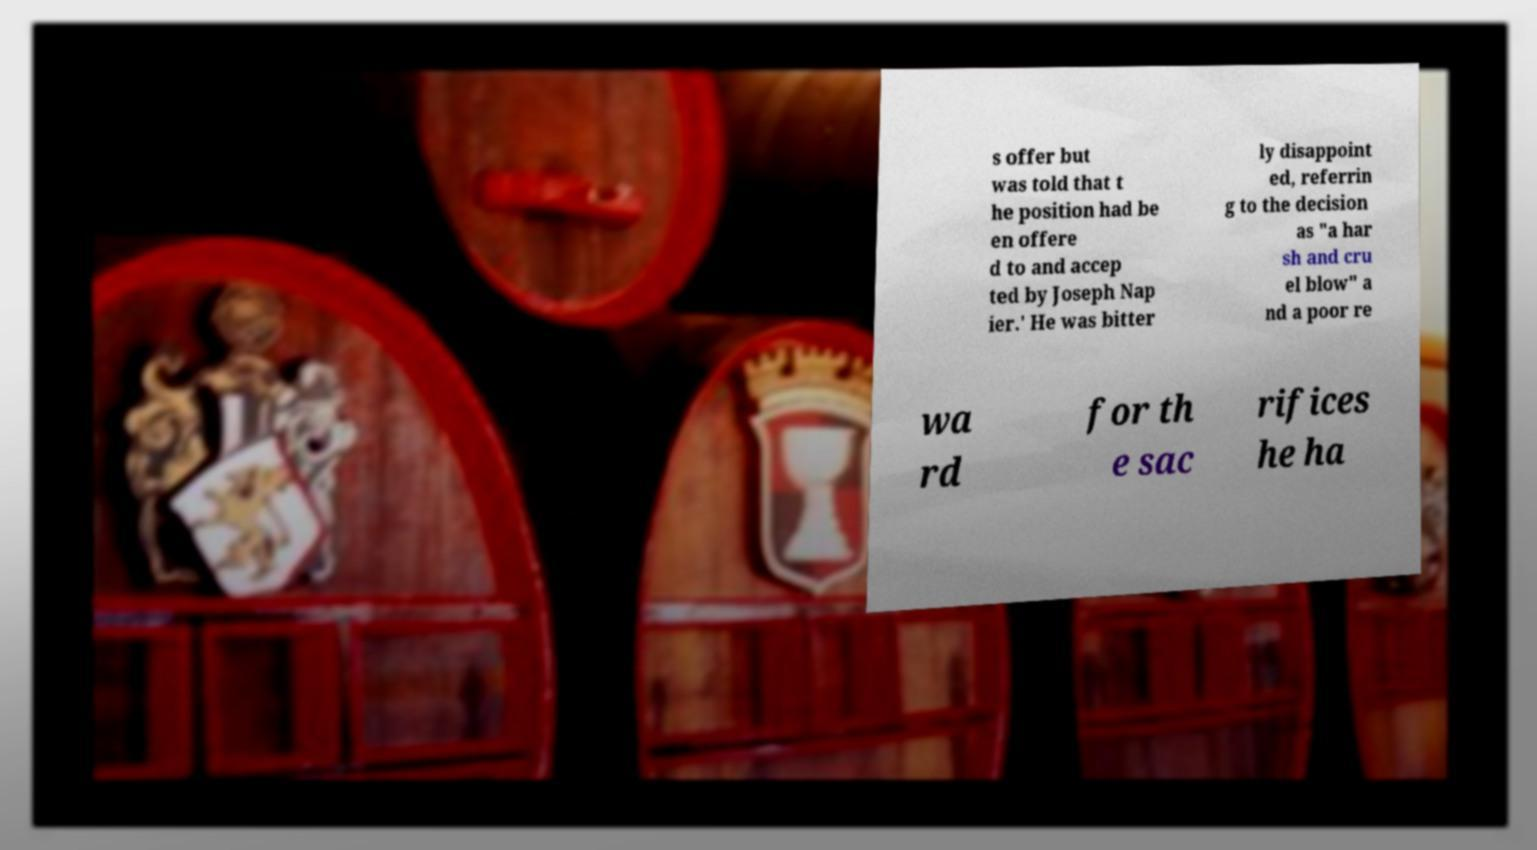Can you read and provide the text displayed in the image?This photo seems to have some interesting text. Can you extract and type it out for me? s offer but was told that t he position had be en offere d to and accep ted by Joseph Nap ier.' He was bitter ly disappoint ed, referrin g to the decision as "a har sh and cru el blow" a nd a poor re wa rd for th e sac rifices he ha 